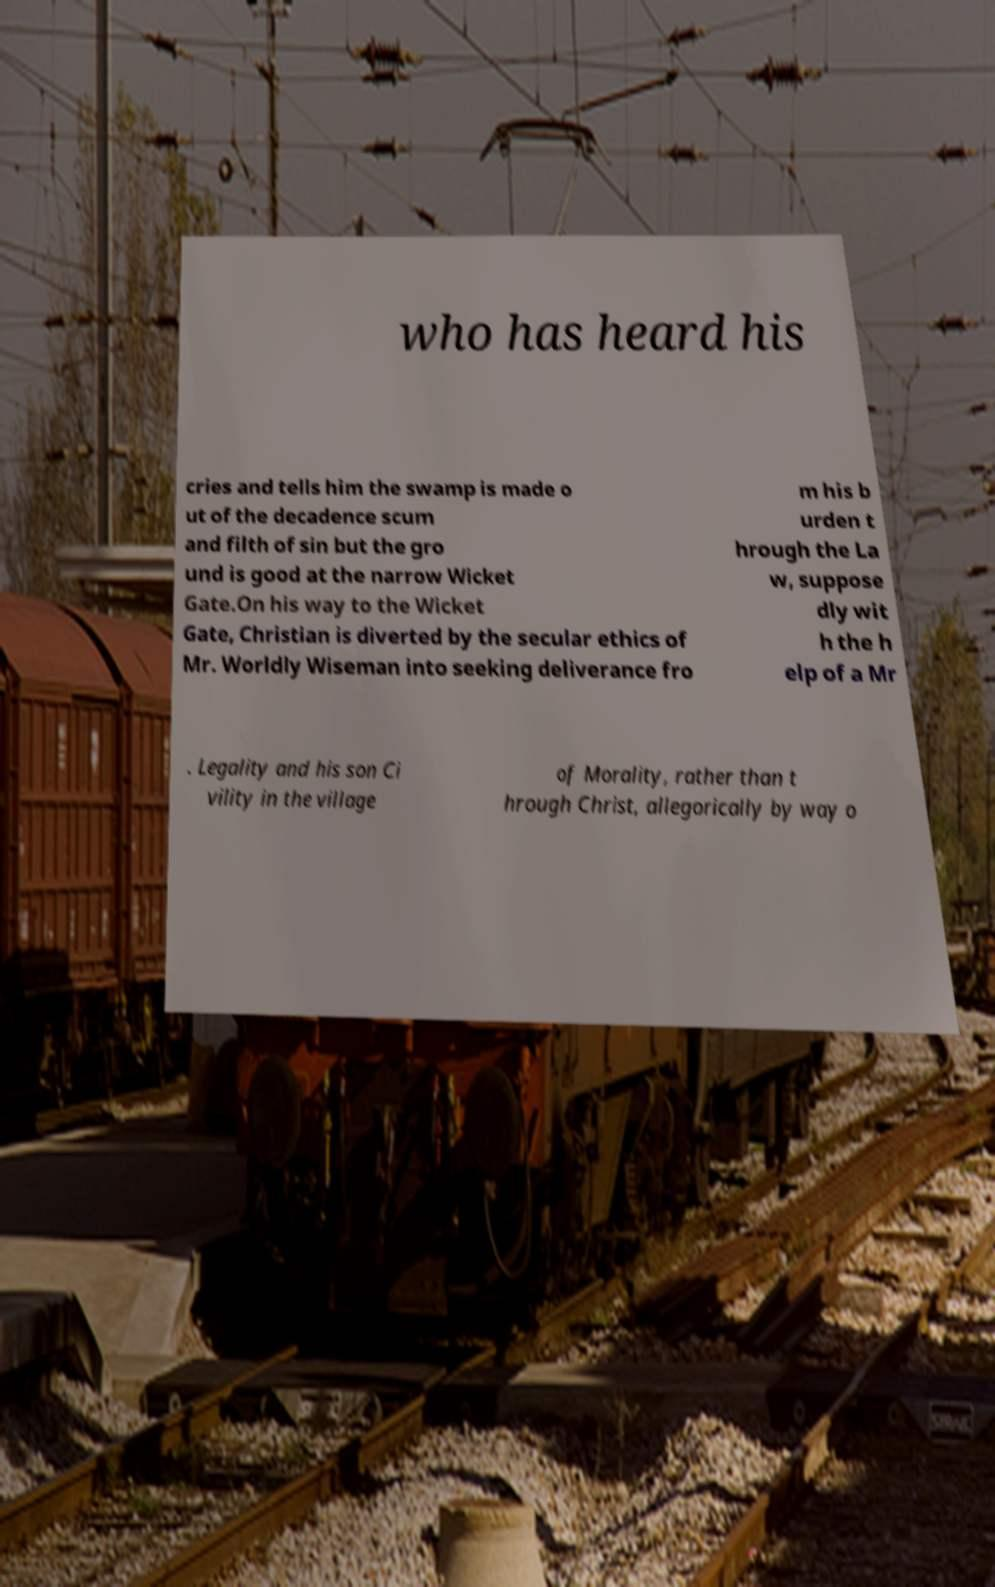Can you read and provide the text displayed in the image?This photo seems to have some interesting text. Can you extract and type it out for me? who has heard his cries and tells him the swamp is made o ut of the decadence scum and filth of sin but the gro und is good at the narrow Wicket Gate.On his way to the Wicket Gate, Christian is diverted by the secular ethics of Mr. Worldly Wiseman into seeking deliverance fro m his b urden t hrough the La w, suppose dly wit h the h elp of a Mr . Legality and his son Ci vility in the village of Morality, rather than t hrough Christ, allegorically by way o 